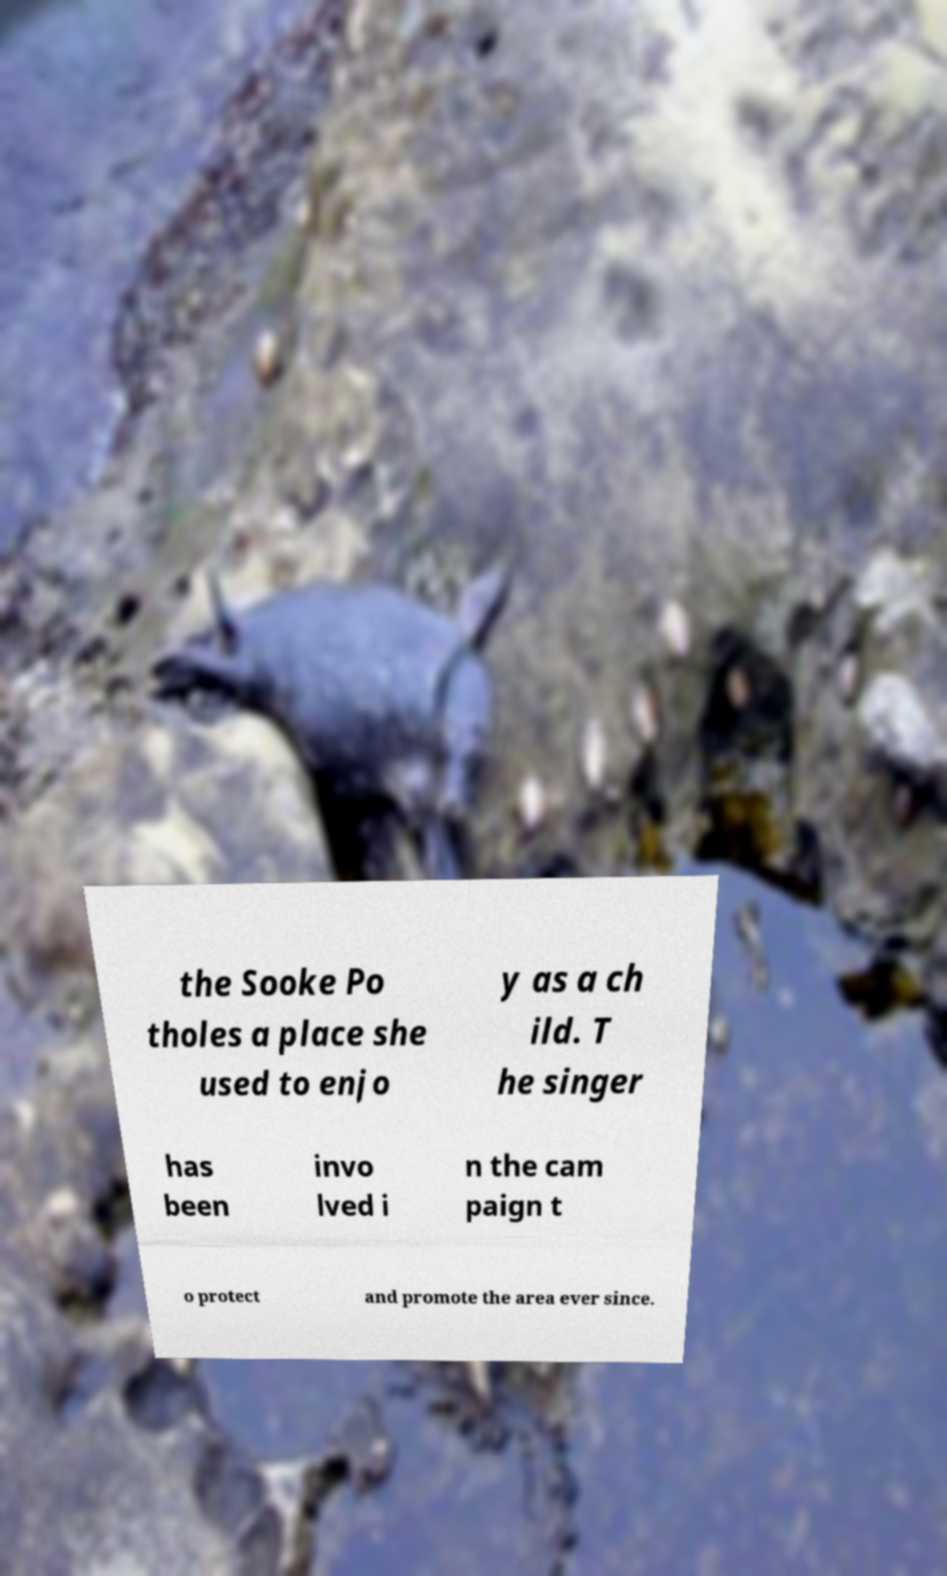Could you extract and type out the text from this image? the Sooke Po tholes a place she used to enjo y as a ch ild. T he singer has been invo lved i n the cam paign t o protect and promote the area ever since. 